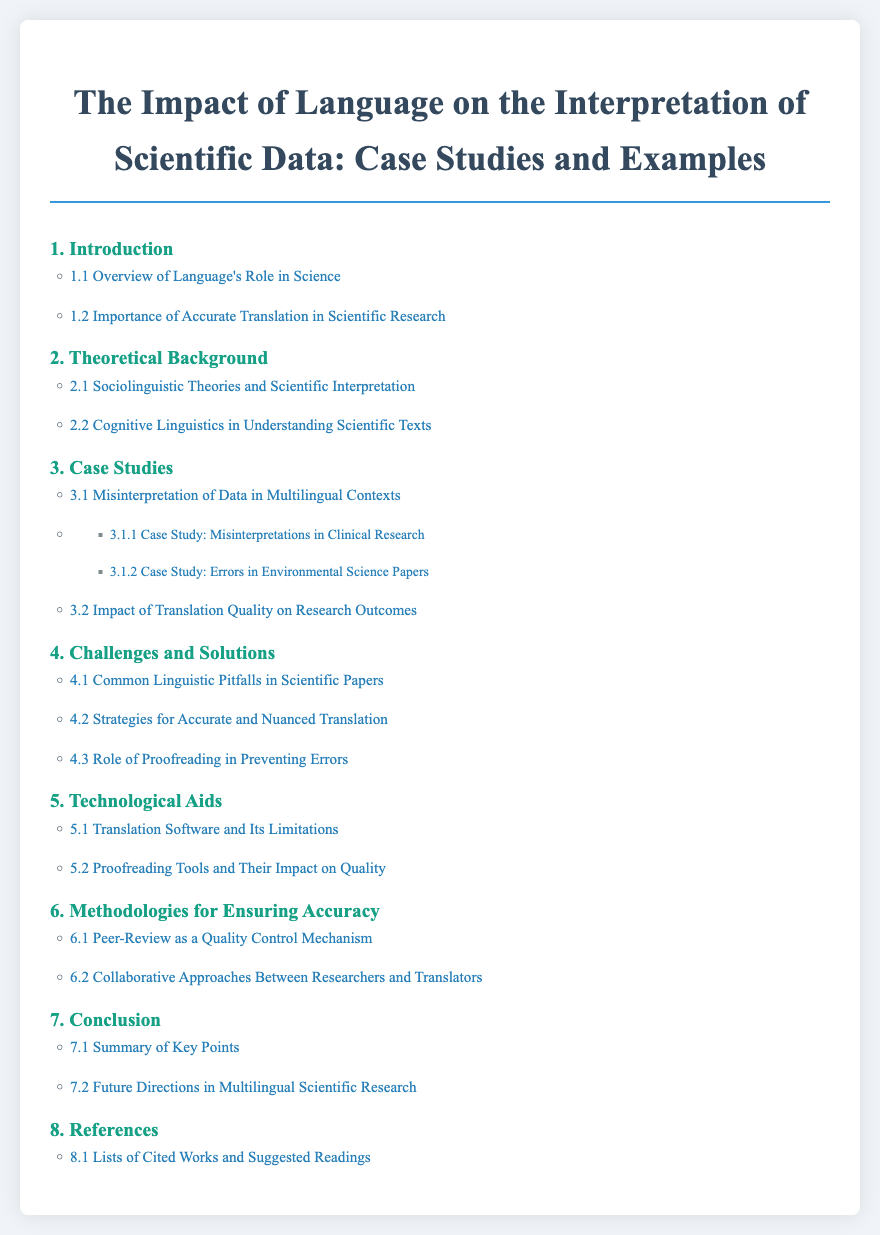1. What is the title of the document? The title is clearly stated at the top of the document, introducing the main topic of discussion.
Answer: The Impact of Language on the Interpretation of Scientific Data: Case Studies and Examples 2. How many sections are listed in the table of contents? By counting the main sections presented in the table of contents, one can find the total number.
Answer: Eight 3. What section covers the role of proofreading? The section focusing on proofreading is specified in the challenges and solutions outlined in the document.
Answer: 4.3 4. Which subsection discusses translation software? The relevant subsection discussing translation software can be found under the section dedicated to technological aids.
Answer: 5.1 5. What are the two types of case studies mentioned? Looking at the case studies section, they are specified as misinterpretations and the impact of translation quality.
Answer: Misinterpretations in Clinical Research, Errors in Environmental Science Papers 6. What is the main topic of section 2? Section 2 addresses theoretical frameworks that inform scientific interpretation, as outlined in the table of contents.
Answer: Theoretical Background 7. Which section discusses future directions in multilingual scientific research? The question pertains to the concluding points made in the document, which typically cover future outlooks.
Answer: 7.2 8. What is one challenge highlighted in section 4? This can be identified by looking at the subsection titles in the challenges and solutions section of the table of contents.
Answer: Common Linguistic Pitfalls in Scientific Papers 